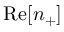Convert formula to latex. <formula><loc_0><loc_0><loc_500><loc_500>R e [ n _ { + } ]</formula> 